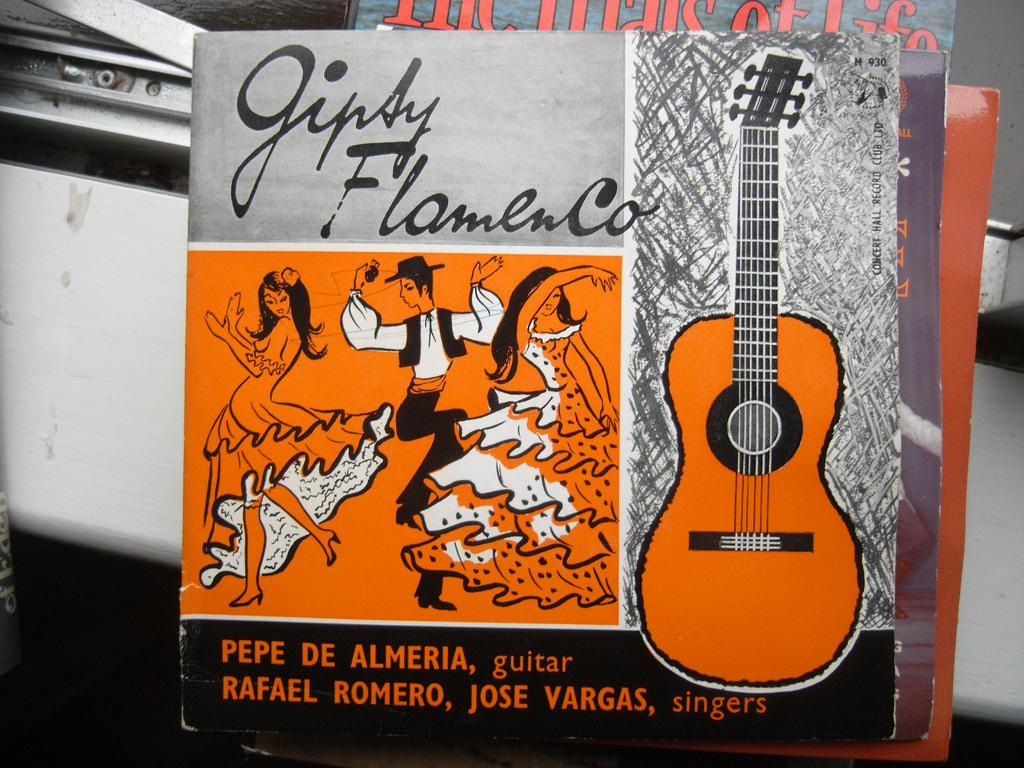What objects are present in the image? There are books in the image. What can be found on the books? The books have text and images on them. Can you see a kitten licking cream off its lips in the image? No, there is no kitten or cream present in the image. 